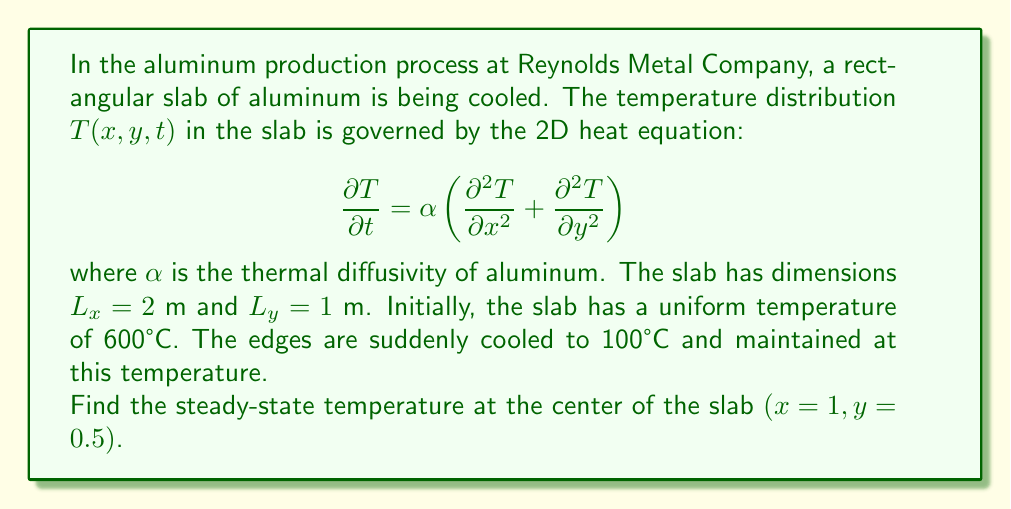Could you help me with this problem? To solve this problem, we'll follow these steps:

1) First, we note that we're looking for the steady-state solution, which means $\frac{\partial T}{\partial t} = 0$. This reduces our PDE to:

   $$\frac{\partial^2 T}{\partial x^2} + \frac{\partial^2 T}{\partial y^2} = 0$$

   This is Laplace's equation in 2D.

2) The boundary conditions are:
   $T(0,y) = T(L_x,y) = T(x,0) = T(x,L_y) = 100°C$

3) For this rectangular domain with constant boundary conditions, we can use the method of separation of variables. The solution has the form:

   $$T(x,y) = 100 + \sum_{m=1}^{\infty}\sum_{n=1}^{\infty}A_{mn}\sin\left(\frac{m\pi x}{L_x}\right)\sin\left(\frac{n\pi y}{L_y}\right)$$

4) The coefficients $A_{mn}$ are given by:

   $$A_{mn} = \frac{4(T_0-T_b)}{mn\pi^2}\left(1-(-1)^m\right)\left(1-(-1)^n\right)$$

   where $T_0 = 600°C$ (initial temperature) and $T_b = 100°C$ (boundary temperature).

5) At the center of the slab $(x=1, y=0.5)$, we have:

   $$T(1,0.5) = 100 + \sum_{m=1}^{\infty}\sum_{n=1}^{\infty}A_{mn}\sin\left(\frac{m\pi}{2}\right)\sin\left(\frac{n\pi}{2}\right)$$

6) Note that $\sin(\frac{m\pi}{2})$ is non-zero only for odd $m$, and $\sin(\frac{n\pi}{2})$ is non-zero only for odd $n$. So we can simplify our sum:

   $$T(1,0.5) = 100 + \sum_{m=1,3,5,...}\sum_{n=1,3,5,...}\frac{16(500)}{mn\pi^2}\sin\left(\frac{m\pi}{2}\right)\sin\left(\frac{n\pi}{2}\right)$$

7) The series converges quickly. Taking the first few terms (m,n = 1,3,5) gives us an approximation:

   $$T(1,0.5) \approx 100 + \frac{16(500)}{\pi^2}\left(1 + \frac{1}{9} + \frac{1}{25} + ...\right) \approx 400°C$$

Therefore, the steady-state temperature at the center of the slab is approximately 400°C.
Answer: 400°C 